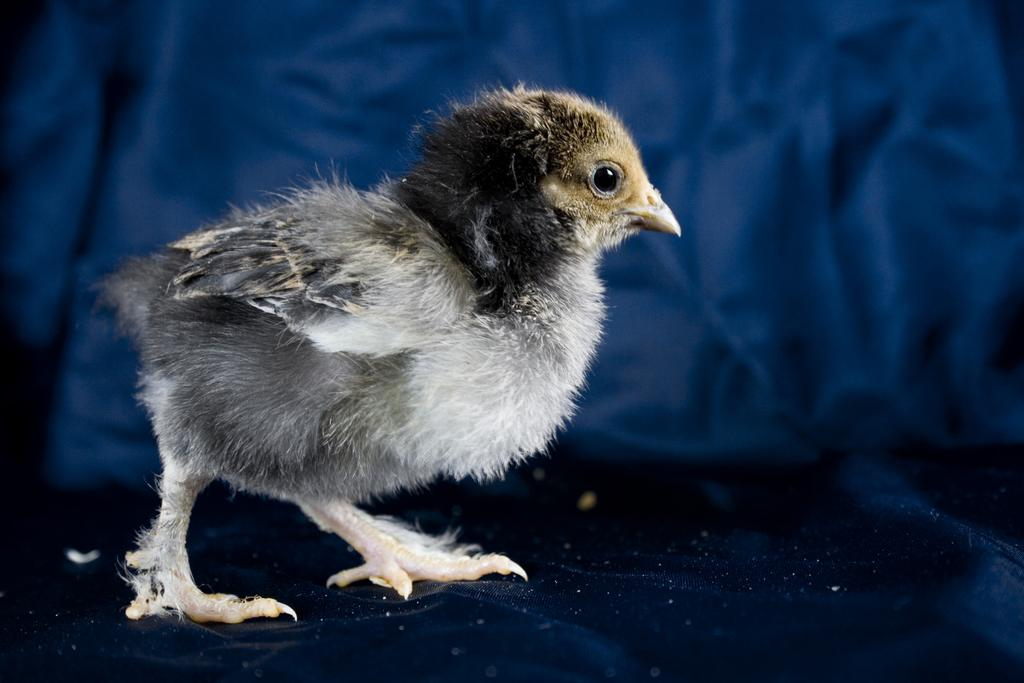What is the main subject of the picture? The main subject of the picture is a chick. What color is the sheet at the bottom of the picture? The sheet at the bottom of the picture is blue in color. What is the color of the background in the picture? The background of the picture is blue in color. Can you describe the lighting conditions in the picture? The picture might have been taken in a dark environment. How many pies are visible in the picture? There are no pies present in the picture; it features a chick and a blue sheet. What type of orange fruit is visible in the picture? There is no orange fruit present in the picture. 